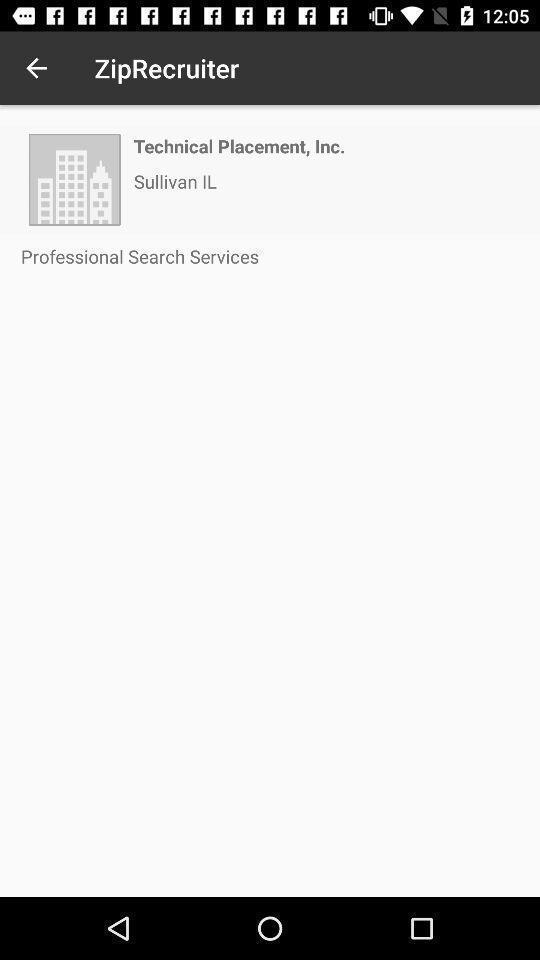Describe the key features of this screenshot. Zip recruiter page of a job search app. 